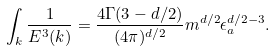Convert formula to latex. <formula><loc_0><loc_0><loc_500><loc_500>\int _ { k } \frac { 1 } { E ^ { 3 } ( { k } ) } = \frac { 4 \Gamma ( 3 - d / 2 ) } { ( 4 \pi ) ^ { d / 2 } } m ^ { d / 2 } \epsilon _ { a } ^ { d / 2 - 3 } .</formula> 